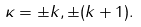<formula> <loc_0><loc_0><loc_500><loc_500>\kappa = \pm k , \pm ( k + 1 ) .</formula> 